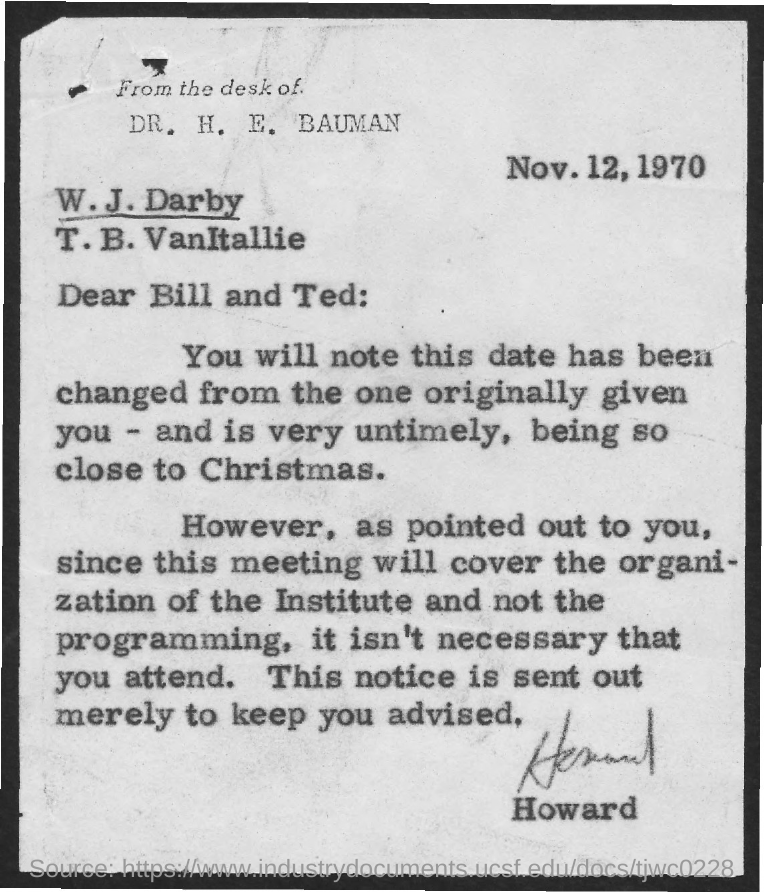What is the date mentioned in the document?
Ensure brevity in your answer.  Nov. 12, 1970. 